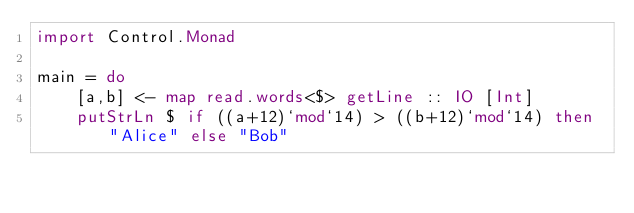Convert code to text. <code><loc_0><loc_0><loc_500><loc_500><_Haskell_>import Control.Monad

main = do
    [a,b] <- map read.words<$> getLine :: IO [Int]
    putStrLn $ if ((a+12)`mod`14) > ((b+12)`mod`14) then "Alice" else "Bob"
</code> 